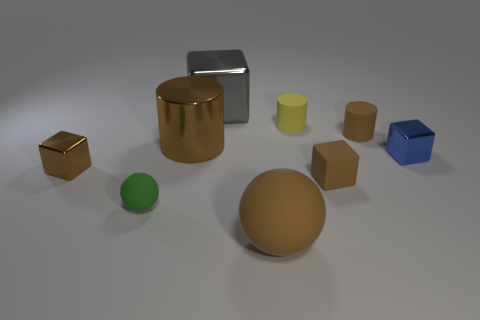There is a tiny yellow matte object; is its shape the same as the brown rubber object behind the small brown rubber block?
Provide a succinct answer. Yes. What number of objects are either objects to the left of the big brown matte sphere or blue things?
Your response must be concise. 5. How many metallic blocks are both in front of the big gray block and on the left side of the big brown matte ball?
Provide a short and direct response. 1. What number of objects are metallic things left of the yellow rubber object or brown objects right of the big brown matte ball?
Keep it short and to the point. 5. What number of other objects are there of the same shape as the small green object?
Offer a very short reply. 1. There is a cylinder on the right side of the tiny yellow thing; is its color the same as the small ball?
Your answer should be compact. No. What number of other objects are the same size as the blue cube?
Your response must be concise. 5. Is the yellow cylinder made of the same material as the small blue object?
Offer a very short reply. No. There is a small cube behind the brown block that is left of the large sphere; what color is it?
Offer a very short reply. Blue. There is a brown rubber object that is the same shape as the tiny brown metal object; what is its size?
Make the answer very short. Small. 